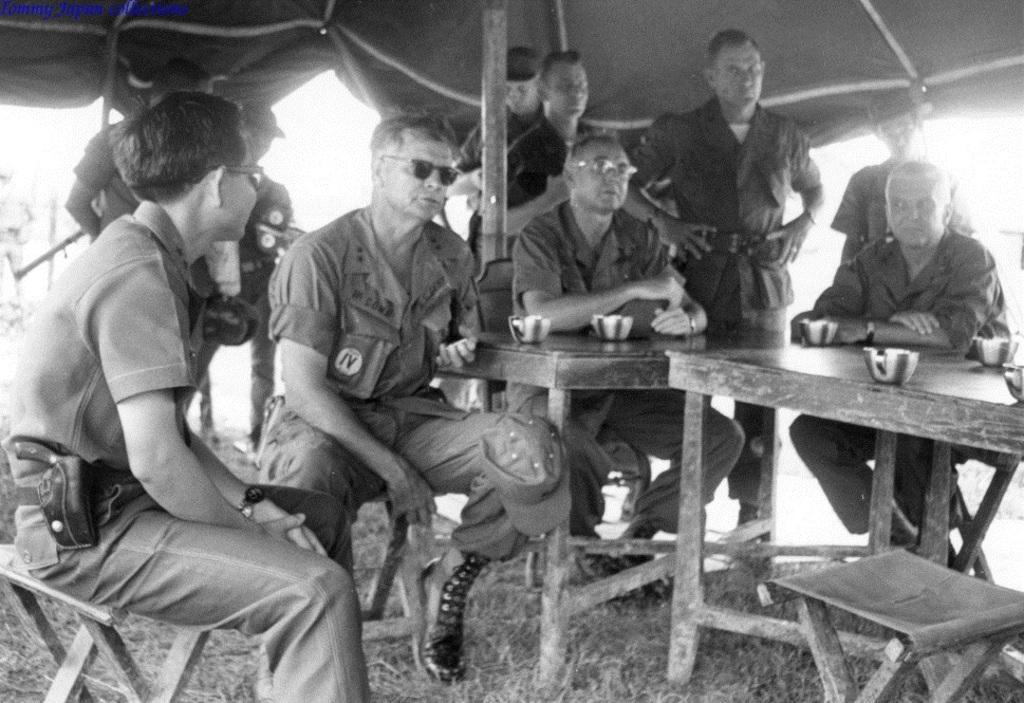How would you summarize this image in a sentence or two? In this image I can see a few people sitting on the bench. On the table there are cups. In front the persons wearing the uniform. This people are sitting under the tent. In front the person is having the gun. 